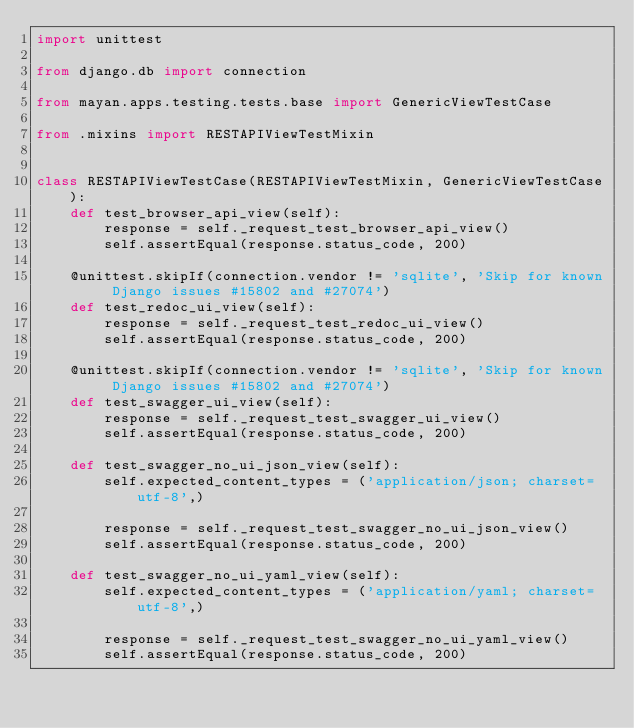Convert code to text. <code><loc_0><loc_0><loc_500><loc_500><_Python_>import unittest

from django.db import connection

from mayan.apps.testing.tests.base import GenericViewTestCase

from .mixins import RESTAPIViewTestMixin


class RESTAPIViewTestCase(RESTAPIViewTestMixin, GenericViewTestCase):
    def test_browser_api_view(self):
        response = self._request_test_browser_api_view()
        self.assertEqual(response.status_code, 200)

    @unittest.skipIf(connection.vendor != 'sqlite', 'Skip for known Django issues #15802 and #27074')
    def test_redoc_ui_view(self):
        response = self._request_test_redoc_ui_view()
        self.assertEqual(response.status_code, 200)

    @unittest.skipIf(connection.vendor != 'sqlite', 'Skip for known Django issues #15802 and #27074')
    def test_swagger_ui_view(self):
        response = self._request_test_swagger_ui_view()
        self.assertEqual(response.status_code, 200)

    def test_swagger_no_ui_json_view(self):
        self.expected_content_types = ('application/json; charset=utf-8',)

        response = self._request_test_swagger_no_ui_json_view()
        self.assertEqual(response.status_code, 200)

    def test_swagger_no_ui_yaml_view(self):
        self.expected_content_types = ('application/yaml; charset=utf-8',)

        response = self._request_test_swagger_no_ui_yaml_view()
        self.assertEqual(response.status_code, 200)
</code> 